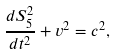<formula> <loc_0><loc_0><loc_500><loc_500>\frac { d S _ { 5 } ^ { 2 } } { d t ^ { 2 } } + v ^ { 2 } = c ^ { 2 } ,</formula> 